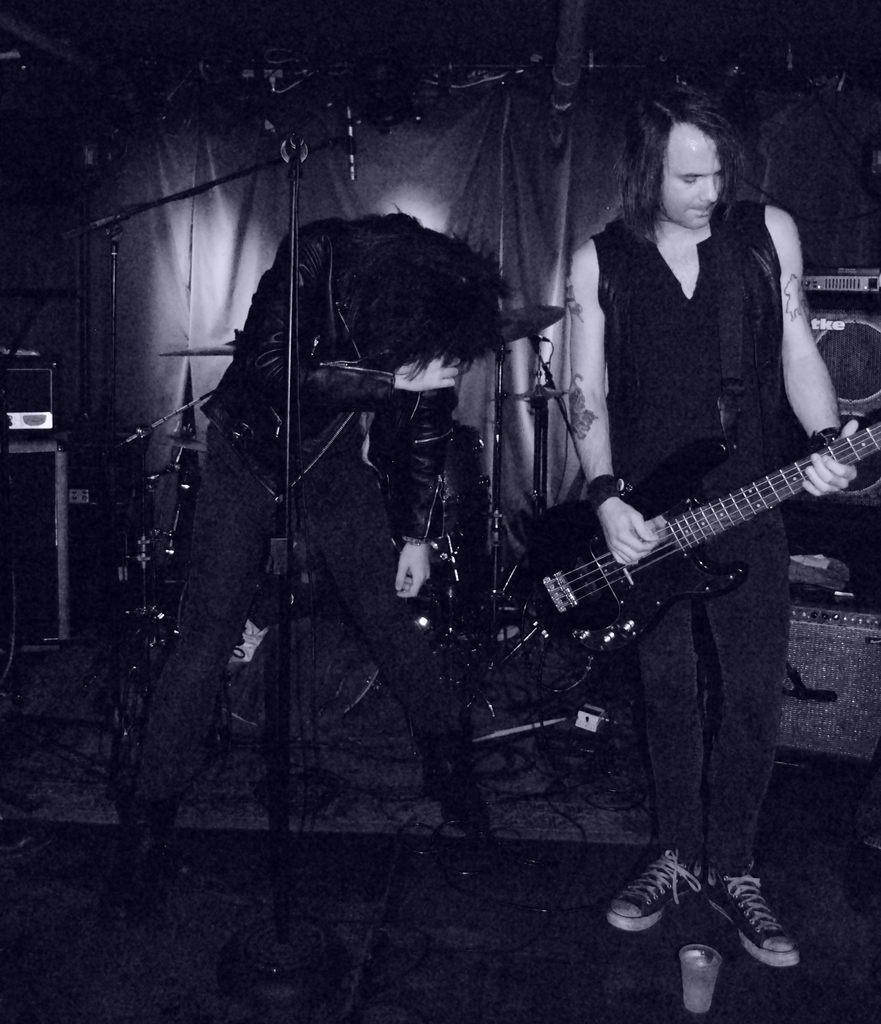In one or two sentences, can you explain what this image depicts? In this picture, there are two persons standing. One is playing a guitar in his hands and the other is standing in front of a microphone. In the background there are some speakers and a curtain here. 